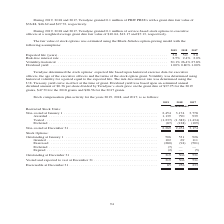According to Teradyne's financial document, How was the risk-free interest rate determined? using the U.S. Treasury yield curve in effect at the time of grant. The document states: "life. The risk-free interest rate was determined using the U.S. Treasury yield curve in effect at the time of grant. Dividend yield was based upon an ..." Also, How was volatility determined? using historical volatility for a period equal to the expected life. The document states: "the stock option grant. Volatility was determined using historical volatility for a period equal to the expected life. The risk-free interest rate was..." Also, In which years was the stock compensation plan activity recorded? The document contains multiple relevant values: 2019, 2018, 2017. From the document: "2019 2018 2017 2019 2018 2017 2019 2018 2017..." Additionally, In which year was the amount of Granted stocks the largest? According to the financial document, 2017. The relevant text states: "2019 2018 2017..." Also, can you calculate: What was the change in granted stocks in 2019 from 2018? Based on the calculation: 102-69, the result is 33 (in thousands). This is based on the information: "standing at January 1 . 506 531 926 Granted . 102 69 111 Exercised . (280) (94) (501) Forfeited . (7) — — Expired . (2) — (5) Outstanding at January 1 . 506 531 926 Granted . 102 69 111 Exercised . (2..." The key data points involved are: 102, 69. Also, can you calculate: What was the percentage change in granted stocks in 2019 from 2018? To answer this question, I need to perform calculations using the financial data. The calculation is: (102-69)/69, which equals 47.83 (percentage). This is based on the information: "standing at January 1 . 506 531 926 Granted . 102 69 111 Exercised . (280) (94) (501) Forfeited . (7) — — Expired . (2) — (5) Outstanding at January 1 . 506 531 926 Granted . 102 69 111 Exercised . (2..." The key data points involved are: 102, 69. 